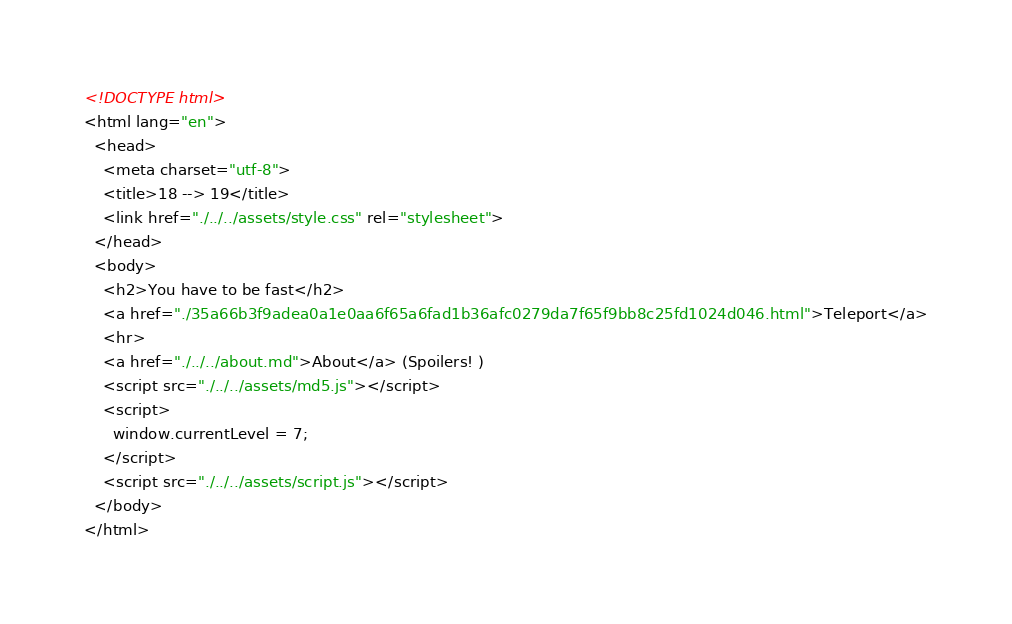Convert code to text. <code><loc_0><loc_0><loc_500><loc_500><_HTML_><!DOCTYPE html>
<html lang="en">
  <head>
    <meta charset="utf-8">
    <title>18 --> 19</title>
    <link href="./../../assets/style.css" rel="stylesheet">
  </head>
  <body>
    <h2>You have to be fast</h2>
    <a href="./35a66b3f9adea0a1e0aa6f65a6fad1b36afc0279da7f65f9bb8c25fd1024d046.html">Teleport</a>
    <hr>
    <a href="./../../about.md">About</a> (Spoilers! )
    <script src="./../../assets/md5.js"></script>
    <script>
      window.currentLevel = 7;
    </script>
    <script src="./../../assets/script.js"></script>
  </body>
</html></code> 